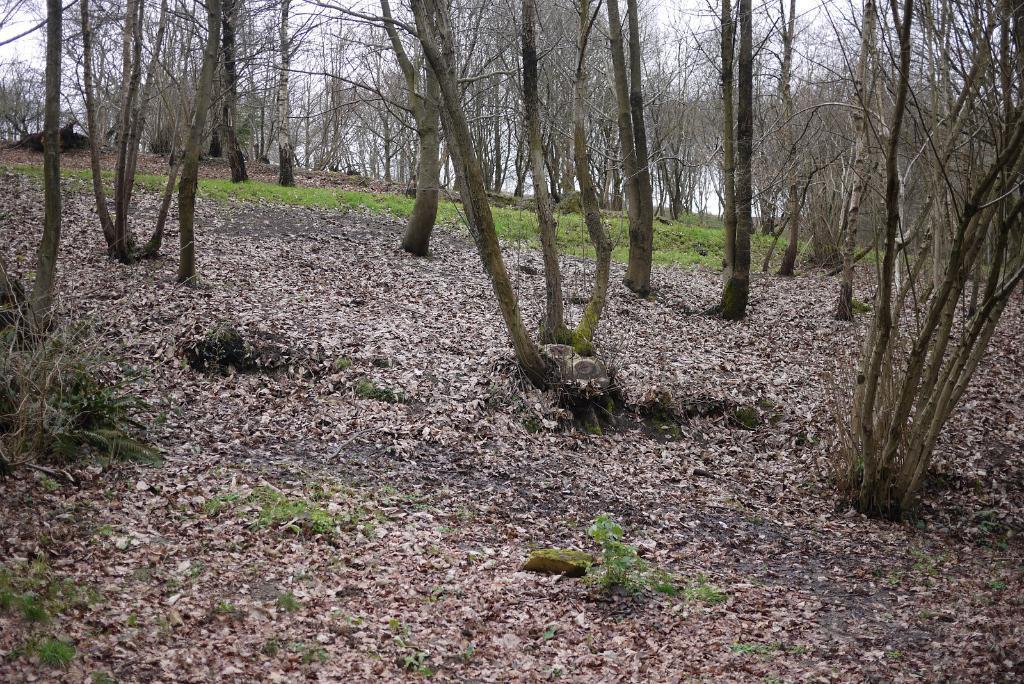Please provide a concise description of this image. In this image we can see grass, plants, dried leaves, and bare trees. In the background there is sky. 